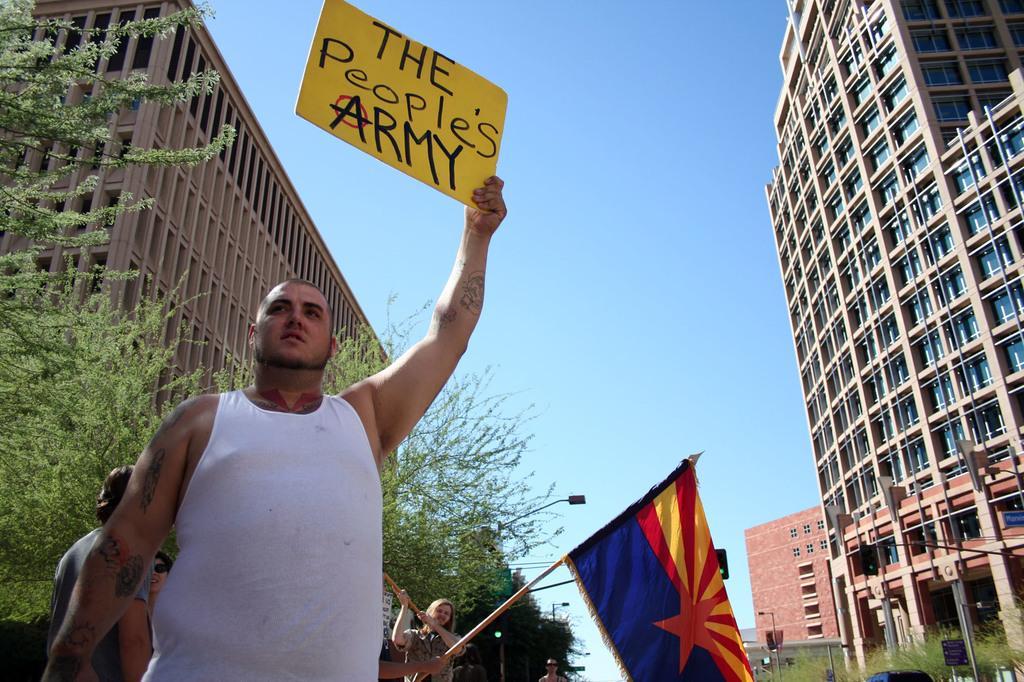Please provide a concise description of this image. Here in this picture, in the front we can see a person standing and holding a play card in his hand and behind him also we can see other people standing with flag post in their hand and we can see buildings present on either side of them and we can see trees and light posts present over there. 